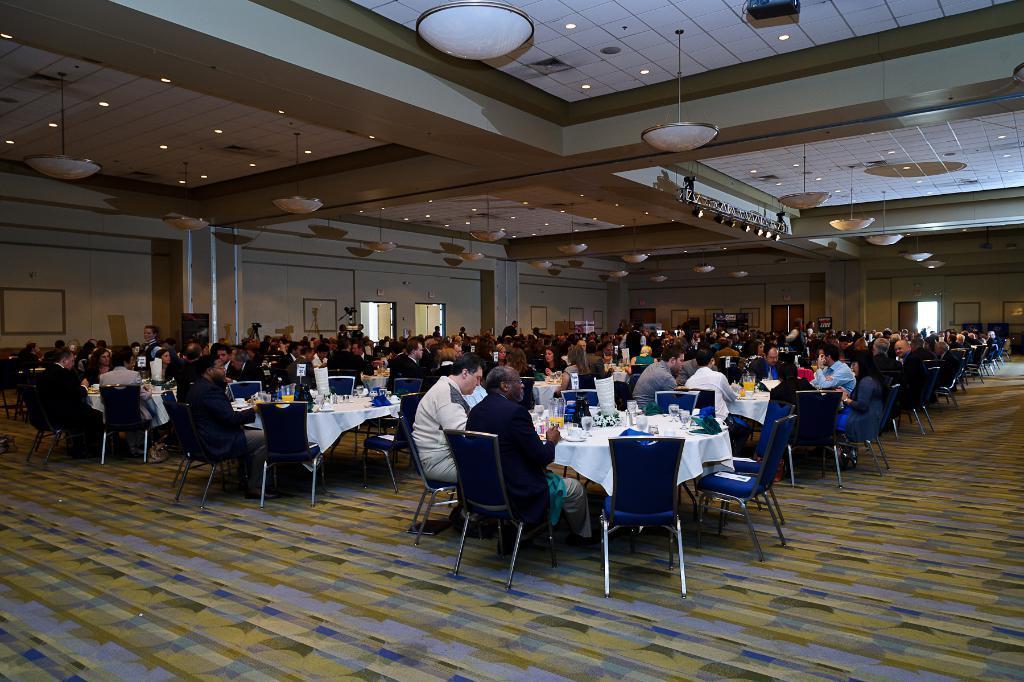Describe this image in one or two sentences. In this picture I can see the inside view of a room. In the front of this picture I can see number of people who are sitting on chairs and there are tables in front of them and on the tables I see few things. In the background I can see the wall. On the top of this picture I can see the ceiling on which there are lights. 